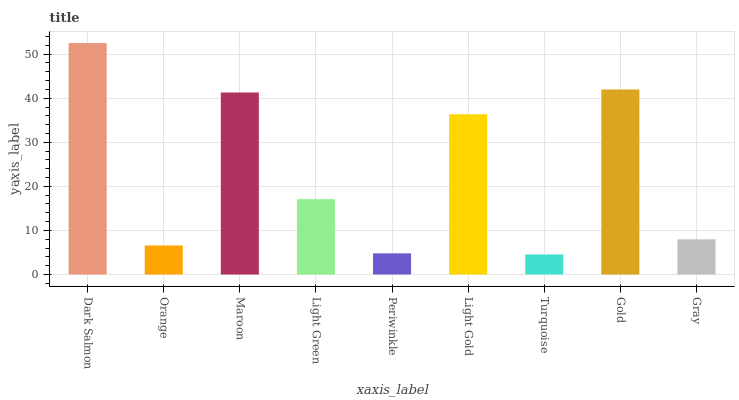Is Orange the minimum?
Answer yes or no. No. Is Orange the maximum?
Answer yes or no. No. Is Dark Salmon greater than Orange?
Answer yes or no. Yes. Is Orange less than Dark Salmon?
Answer yes or no. Yes. Is Orange greater than Dark Salmon?
Answer yes or no. No. Is Dark Salmon less than Orange?
Answer yes or no. No. Is Light Green the high median?
Answer yes or no. Yes. Is Light Green the low median?
Answer yes or no. Yes. Is Maroon the high median?
Answer yes or no. No. Is Turquoise the low median?
Answer yes or no. No. 